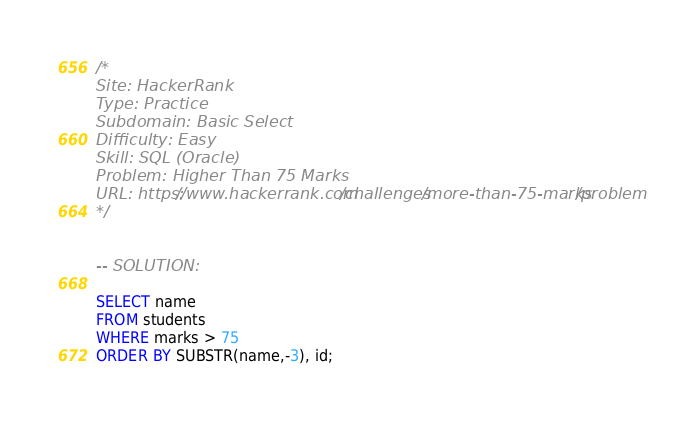Convert code to text. <code><loc_0><loc_0><loc_500><loc_500><_SQL_>/*
Site: HackerRank
Type: Practice
Subdomain: Basic Select
Difficulty: Easy
Skill: SQL (Oracle)
Problem: Higher Than 75 Marks
URL: https://www.hackerrank.com/challenges/more-than-75-marks/problem
*/


-- SOLUTION:

SELECT name
FROM students
WHERE marks > 75
ORDER BY SUBSTR(name,-3), id;</code> 